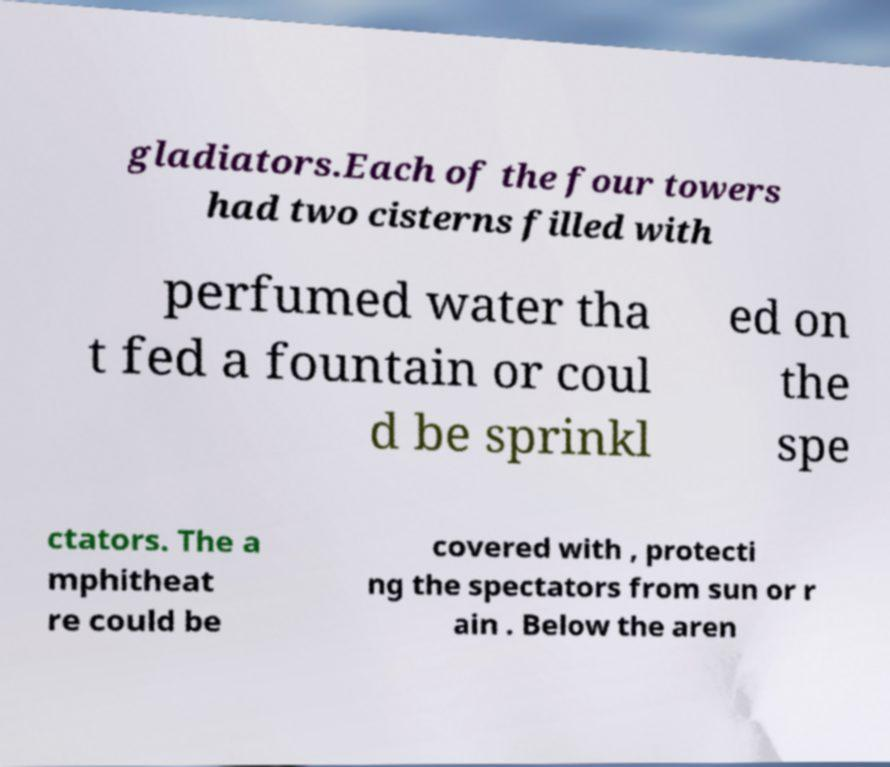Could you assist in decoding the text presented in this image and type it out clearly? gladiators.Each of the four towers had two cisterns filled with perfumed water tha t fed a fountain or coul d be sprinkl ed on the spe ctators. The a mphitheat re could be covered with , protecti ng the spectators from sun or r ain . Below the aren 